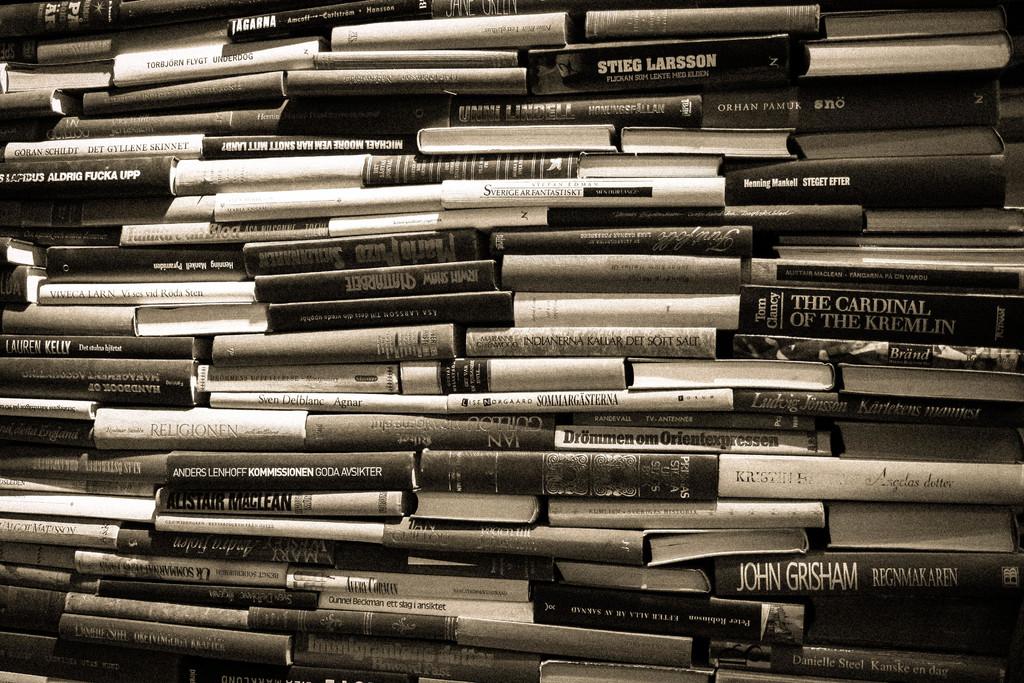What is the name of one of the authors?
Make the answer very short. John grisham. 